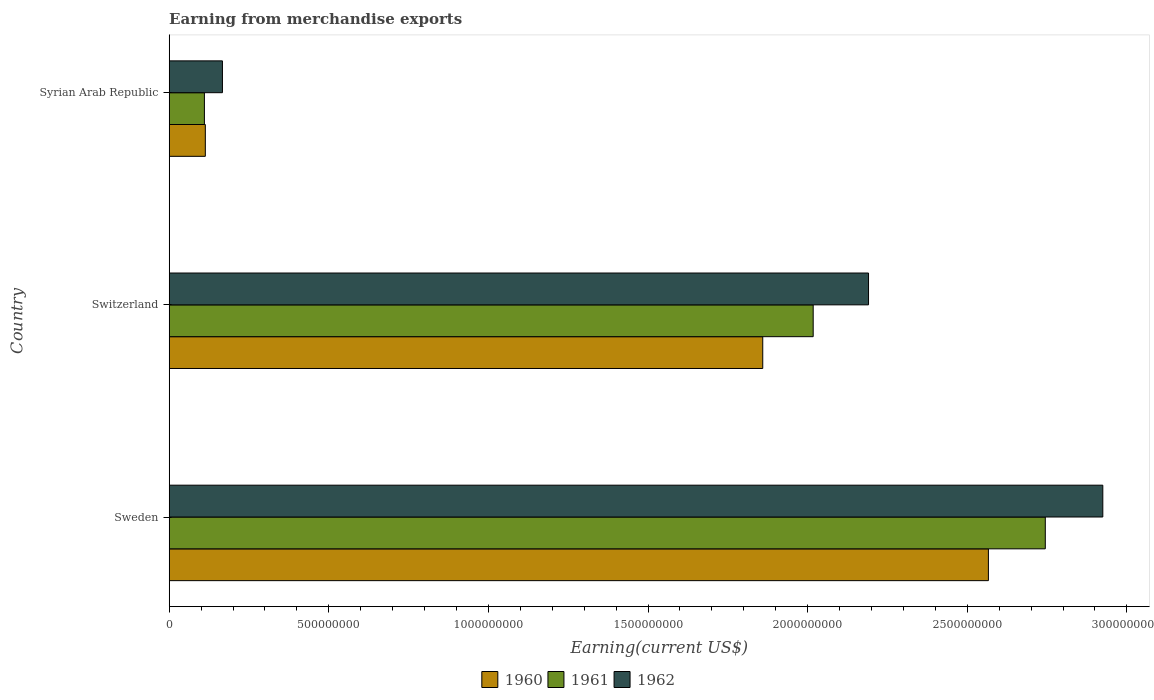How many groups of bars are there?
Keep it short and to the point. 3. Are the number of bars on each tick of the Y-axis equal?
Your answer should be very brief. Yes. How many bars are there on the 3rd tick from the top?
Make the answer very short. 3. How many bars are there on the 3rd tick from the bottom?
Offer a very short reply. 3. In how many cases, is the number of bars for a given country not equal to the number of legend labels?
Provide a short and direct response. 0. What is the amount earned from merchandise exports in 1960 in Sweden?
Your response must be concise. 2.57e+09. Across all countries, what is the maximum amount earned from merchandise exports in 1962?
Your answer should be compact. 2.92e+09. Across all countries, what is the minimum amount earned from merchandise exports in 1961?
Provide a succinct answer. 1.10e+08. In which country was the amount earned from merchandise exports in 1962 minimum?
Keep it short and to the point. Syrian Arab Republic. What is the total amount earned from merchandise exports in 1961 in the graph?
Your answer should be compact. 4.87e+09. What is the difference between the amount earned from merchandise exports in 1960 in Sweden and that in Syrian Arab Republic?
Your answer should be very brief. 2.45e+09. What is the difference between the amount earned from merchandise exports in 1960 in Syrian Arab Republic and the amount earned from merchandise exports in 1962 in Sweden?
Offer a terse response. -2.81e+09. What is the average amount earned from merchandise exports in 1962 per country?
Make the answer very short. 1.76e+09. What is the difference between the amount earned from merchandise exports in 1962 and amount earned from merchandise exports in 1961 in Sweden?
Your answer should be compact. 1.80e+08. In how many countries, is the amount earned from merchandise exports in 1961 greater than 500000000 US$?
Ensure brevity in your answer.  2. What is the ratio of the amount earned from merchandise exports in 1961 in Sweden to that in Syrian Arab Republic?
Ensure brevity in your answer.  24.89. Is the difference between the amount earned from merchandise exports in 1962 in Switzerland and Syrian Arab Republic greater than the difference between the amount earned from merchandise exports in 1961 in Switzerland and Syrian Arab Republic?
Give a very brief answer. Yes. What is the difference between the highest and the second highest amount earned from merchandise exports in 1960?
Offer a very short reply. 7.07e+08. What is the difference between the highest and the lowest amount earned from merchandise exports in 1961?
Keep it short and to the point. 2.63e+09. Is the sum of the amount earned from merchandise exports in 1960 in Sweden and Syrian Arab Republic greater than the maximum amount earned from merchandise exports in 1961 across all countries?
Provide a succinct answer. No. What does the 3rd bar from the top in Switzerland represents?
Offer a terse response. 1960. Is it the case that in every country, the sum of the amount earned from merchandise exports in 1962 and amount earned from merchandise exports in 1961 is greater than the amount earned from merchandise exports in 1960?
Offer a very short reply. Yes. Are all the bars in the graph horizontal?
Provide a short and direct response. Yes. How many countries are there in the graph?
Your answer should be compact. 3. What is the difference between two consecutive major ticks on the X-axis?
Offer a very short reply. 5.00e+08. Are the values on the major ticks of X-axis written in scientific E-notation?
Provide a short and direct response. No. How many legend labels are there?
Provide a short and direct response. 3. How are the legend labels stacked?
Ensure brevity in your answer.  Horizontal. What is the title of the graph?
Your response must be concise. Earning from merchandise exports. Does "2007" appear as one of the legend labels in the graph?
Provide a short and direct response. No. What is the label or title of the X-axis?
Give a very brief answer. Earning(current US$). What is the Earning(current US$) in 1960 in Sweden?
Give a very brief answer. 2.57e+09. What is the Earning(current US$) of 1961 in Sweden?
Offer a very short reply. 2.74e+09. What is the Earning(current US$) in 1962 in Sweden?
Your response must be concise. 2.92e+09. What is the Earning(current US$) of 1960 in Switzerland?
Offer a very short reply. 1.86e+09. What is the Earning(current US$) in 1961 in Switzerland?
Give a very brief answer. 2.02e+09. What is the Earning(current US$) in 1962 in Switzerland?
Ensure brevity in your answer.  2.19e+09. What is the Earning(current US$) in 1960 in Syrian Arab Republic?
Your answer should be very brief. 1.13e+08. What is the Earning(current US$) in 1961 in Syrian Arab Republic?
Keep it short and to the point. 1.10e+08. What is the Earning(current US$) in 1962 in Syrian Arab Republic?
Provide a succinct answer. 1.67e+08. Across all countries, what is the maximum Earning(current US$) in 1960?
Keep it short and to the point. 2.57e+09. Across all countries, what is the maximum Earning(current US$) of 1961?
Keep it short and to the point. 2.74e+09. Across all countries, what is the maximum Earning(current US$) of 1962?
Your response must be concise. 2.92e+09. Across all countries, what is the minimum Earning(current US$) of 1960?
Offer a very short reply. 1.13e+08. Across all countries, what is the minimum Earning(current US$) of 1961?
Provide a succinct answer. 1.10e+08. Across all countries, what is the minimum Earning(current US$) in 1962?
Provide a short and direct response. 1.67e+08. What is the total Earning(current US$) of 1960 in the graph?
Your response must be concise. 4.54e+09. What is the total Earning(current US$) of 1961 in the graph?
Provide a short and direct response. 4.87e+09. What is the total Earning(current US$) in 1962 in the graph?
Give a very brief answer. 5.28e+09. What is the difference between the Earning(current US$) in 1960 in Sweden and that in Switzerland?
Provide a succinct answer. 7.07e+08. What is the difference between the Earning(current US$) in 1961 in Sweden and that in Switzerland?
Ensure brevity in your answer.  7.27e+08. What is the difference between the Earning(current US$) in 1962 in Sweden and that in Switzerland?
Keep it short and to the point. 7.34e+08. What is the difference between the Earning(current US$) of 1960 in Sweden and that in Syrian Arab Republic?
Provide a succinct answer. 2.45e+09. What is the difference between the Earning(current US$) of 1961 in Sweden and that in Syrian Arab Republic?
Provide a succinct answer. 2.63e+09. What is the difference between the Earning(current US$) of 1962 in Sweden and that in Syrian Arab Republic?
Give a very brief answer. 2.76e+09. What is the difference between the Earning(current US$) of 1960 in Switzerland and that in Syrian Arab Republic?
Provide a succinct answer. 1.75e+09. What is the difference between the Earning(current US$) of 1961 in Switzerland and that in Syrian Arab Republic?
Offer a terse response. 1.91e+09. What is the difference between the Earning(current US$) in 1962 in Switzerland and that in Syrian Arab Republic?
Your response must be concise. 2.02e+09. What is the difference between the Earning(current US$) of 1960 in Sweden and the Earning(current US$) of 1961 in Switzerland?
Your answer should be compact. 5.49e+08. What is the difference between the Earning(current US$) of 1960 in Sweden and the Earning(current US$) of 1962 in Switzerland?
Offer a terse response. 3.76e+08. What is the difference between the Earning(current US$) in 1961 in Sweden and the Earning(current US$) in 1962 in Switzerland?
Your answer should be very brief. 5.54e+08. What is the difference between the Earning(current US$) of 1960 in Sweden and the Earning(current US$) of 1961 in Syrian Arab Republic?
Give a very brief answer. 2.46e+09. What is the difference between the Earning(current US$) in 1960 in Sweden and the Earning(current US$) in 1962 in Syrian Arab Republic?
Your answer should be very brief. 2.40e+09. What is the difference between the Earning(current US$) of 1961 in Sweden and the Earning(current US$) of 1962 in Syrian Arab Republic?
Provide a succinct answer. 2.58e+09. What is the difference between the Earning(current US$) of 1960 in Switzerland and the Earning(current US$) of 1961 in Syrian Arab Republic?
Keep it short and to the point. 1.75e+09. What is the difference between the Earning(current US$) in 1960 in Switzerland and the Earning(current US$) in 1962 in Syrian Arab Republic?
Your response must be concise. 1.69e+09. What is the difference between the Earning(current US$) in 1961 in Switzerland and the Earning(current US$) in 1962 in Syrian Arab Republic?
Offer a very short reply. 1.85e+09. What is the average Earning(current US$) in 1960 per country?
Offer a very short reply. 1.51e+09. What is the average Earning(current US$) in 1961 per country?
Offer a very short reply. 1.62e+09. What is the average Earning(current US$) of 1962 per country?
Give a very brief answer. 1.76e+09. What is the difference between the Earning(current US$) of 1960 and Earning(current US$) of 1961 in Sweden?
Keep it short and to the point. -1.78e+08. What is the difference between the Earning(current US$) in 1960 and Earning(current US$) in 1962 in Sweden?
Your response must be concise. -3.58e+08. What is the difference between the Earning(current US$) in 1961 and Earning(current US$) in 1962 in Sweden?
Your answer should be very brief. -1.80e+08. What is the difference between the Earning(current US$) of 1960 and Earning(current US$) of 1961 in Switzerland?
Give a very brief answer. -1.58e+08. What is the difference between the Earning(current US$) of 1960 and Earning(current US$) of 1962 in Switzerland?
Keep it short and to the point. -3.31e+08. What is the difference between the Earning(current US$) of 1961 and Earning(current US$) of 1962 in Switzerland?
Your answer should be compact. -1.73e+08. What is the difference between the Earning(current US$) in 1960 and Earning(current US$) in 1961 in Syrian Arab Republic?
Provide a short and direct response. 2.88e+06. What is the difference between the Earning(current US$) of 1960 and Earning(current US$) of 1962 in Syrian Arab Republic?
Offer a very short reply. -5.36e+07. What is the difference between the Earning(current US$) in 1961 and Earning(current US$) in 1962 in Syrian Arab Republic?
Ensure brevity in your answer.  -5.65e+07. What is the ratio of the Earning(current US$) of 1960 in Sweden to that in Switzerland?
Ensure brevity in your answer.  1.38. What is the ratio of the Earning(current US$) of 1961 in Sweden to that in Switzerland?
Give a very brief answer. 1.36. What is the ratio of the Earning(current US$) in 1962 in Sweden to that in Switzerland?
Provide a short and direct response. 1.33. What is the ratio of the Earning(current US$) of 1960 in Sweden to that in Syrian Arab Republic?
Give a very brief answer. 22.68. What is the ratio of the Earning(current US$) of 1961 in Sweden to that in Syrian Arab Republic?
Offer a very short reply. 24.89. What is the ratio of the Earning(current US$) of 1962 in Sweden to that in Syrian Arab Republic?
Provide a succinct answer. 17.54. What is the ratio of the Earning(current US$) in 1960 in Switzerland to that in Syrian Arab Republic?
Provide a short and direct response. 16.43. What is the ratio of the Earning(current US$) in 1961 in Switzerland to that in Syrian Arab Republic?
Ensure brevity in your answer.  18.29. What is the ratio of the Earning(current US$) of 1962 in Switzerland to that in Syrian Arab Republic?
Keep it short and to the point. 13.14. What is the difference between the highest and the second highest Earning(current US$) of 1960?
Provide a short and direct response. 7.07e+08. What is the difference between the highest and the second highest Earning(current US$) of 1961?
Provide a succinct answer. 7.27e+08. What is the difference between the highest and the second highest Earning(current US$) in 1962?
Make the answer very short. 7.34e+08. What is the difference between the highest and the lowest Earning(current US$) of 1960?
Offer a terse response. 2.45e+09. What is the difference between the highest and the lowest Earning(current US$) in 1961?
Make the answer very short. 2.63e+09. What is the difference between the highest and the lowest Earning(current US$) of 1962?
Provide a short and direct response. 2.76e+09. 